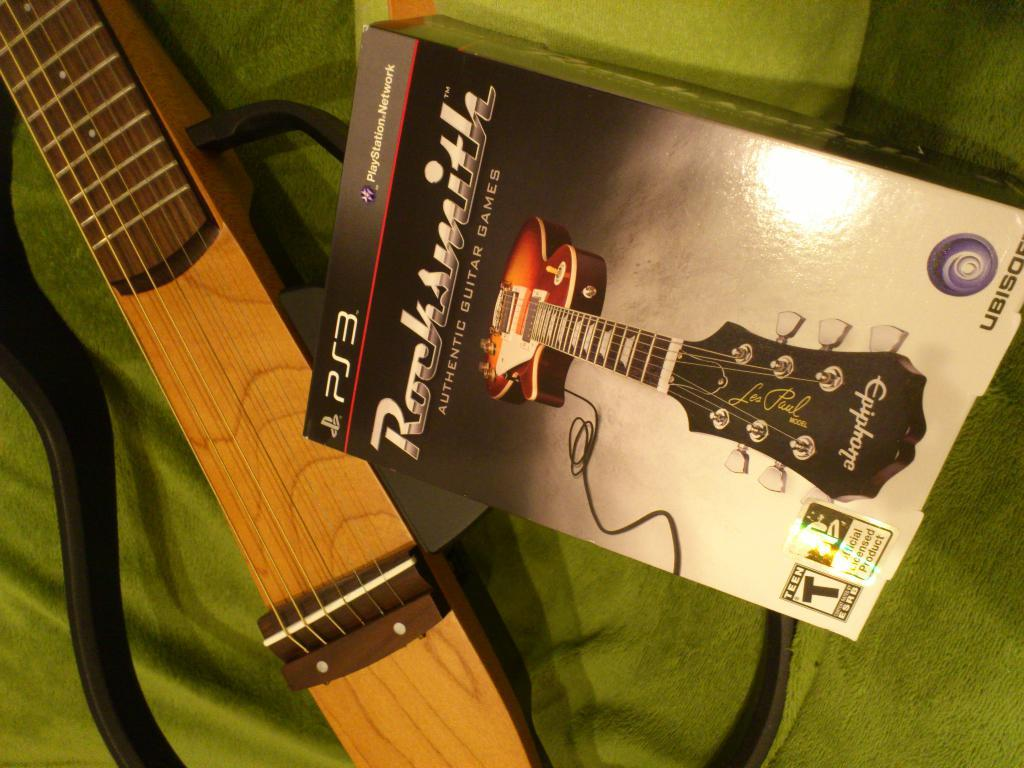Provide a one-sentence caption for the provided image. A guitar sits next to a Rocksmith's Authentic Guitar Games game for Playstation 3. 